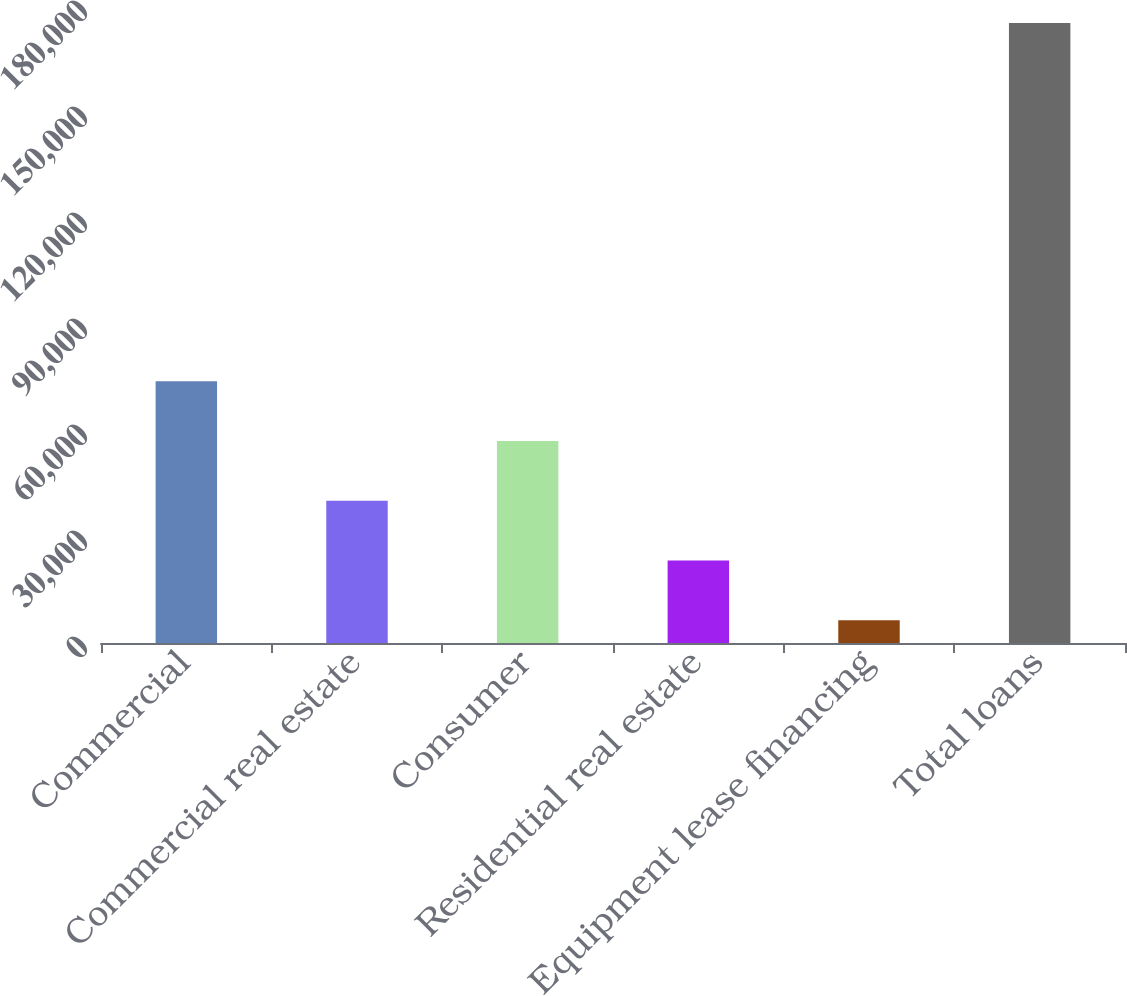<chart> <loc_0><loc_0><loc_500><loc_500><bar_chart><fcel>Commercial<fcel>Commercial real estate<fcel>Consumer<fcel>Residential real estate<fcel>Equipment lease financing<fcel>Total loans<nl><fcel>74072.2<fcel>40266.6<fcel>57169.4<fcel>23363.8<fcel>6461<fcel>175489<nl></chart> 